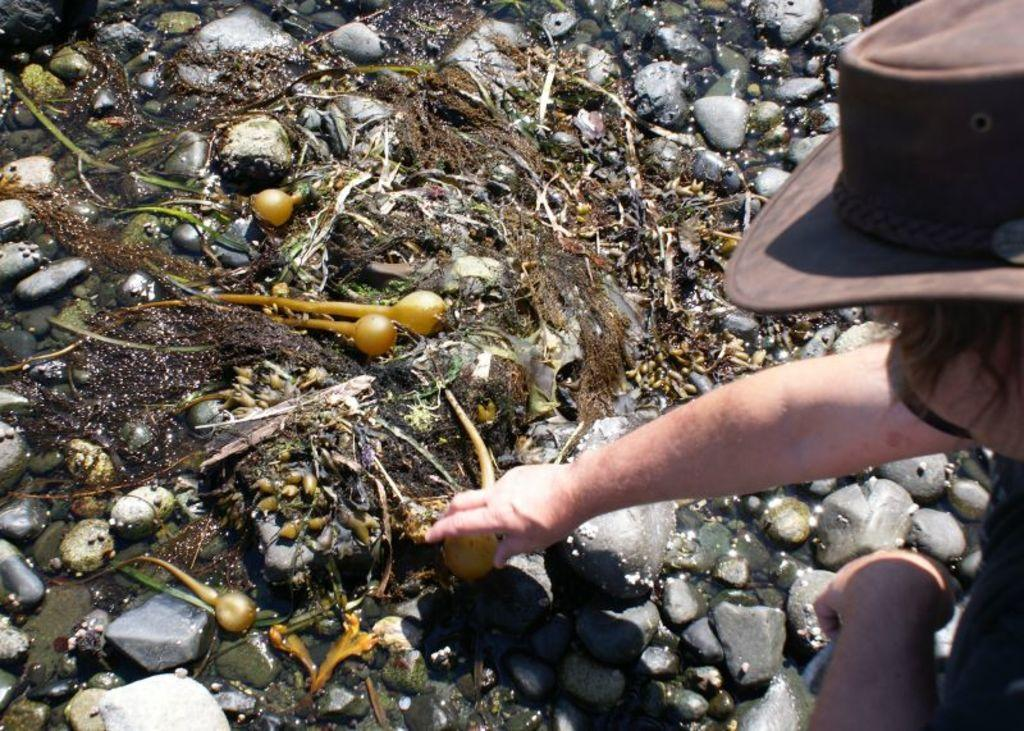What type of objects can be seen in the image? There are stones in the image. Can you describe the person in the image? There is a person wearing a cap in the image. What type of desk is visible in the image? There is no desk present in the image. Is the person holding an umbrella in the image? There is no umbrella present in the image. 